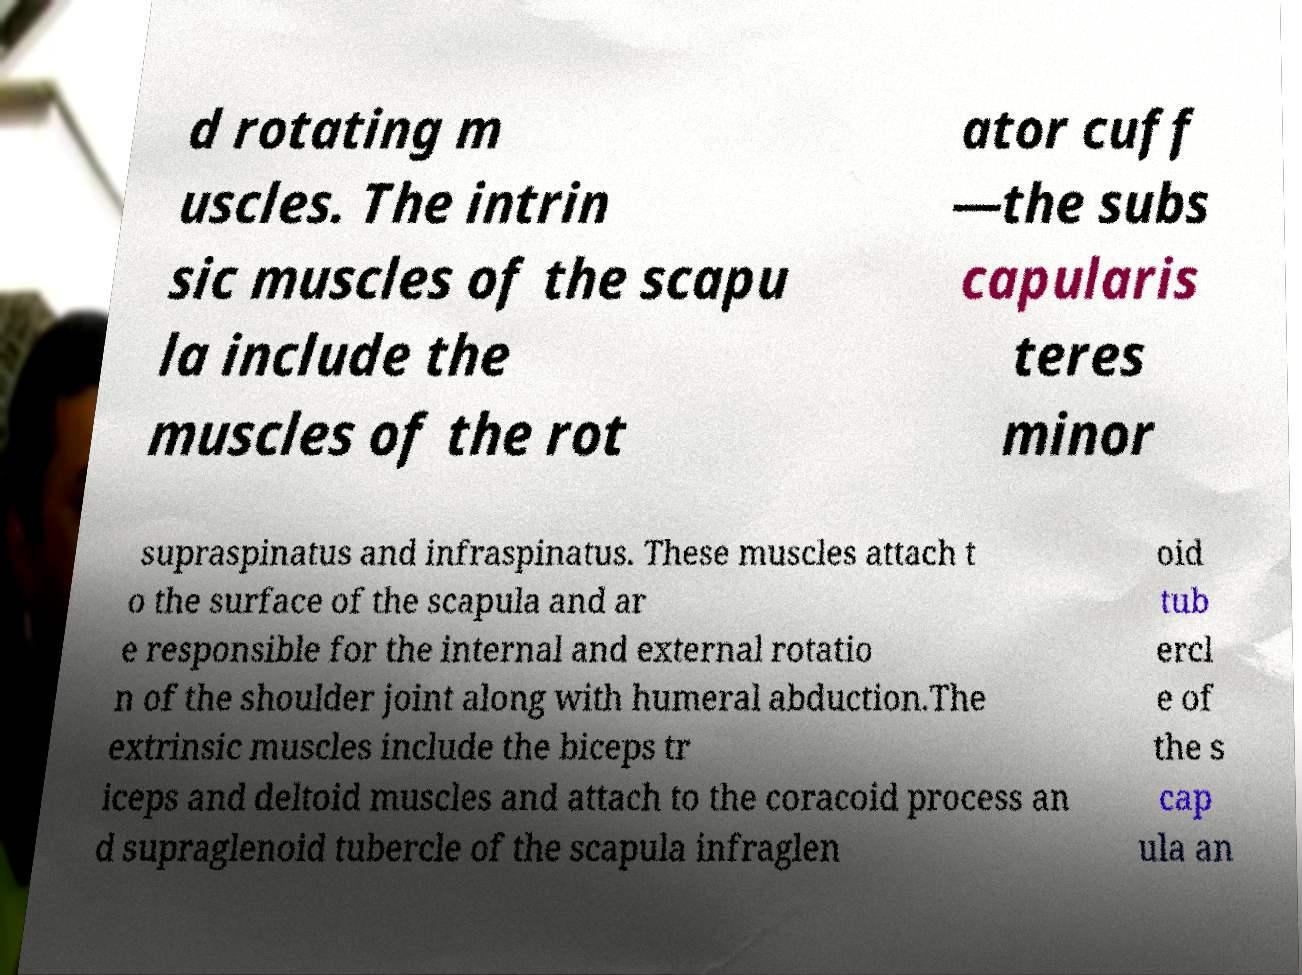Please identify and transcribe the text found in this image. d rotating m uscles. The intrin sic muscles of the scapu la include the muscles of the rot ator cuff —the subs capularis teres minor supraspinatus and infraspinatus. These muscles attach t o the surface of the scapula and ar e responsible for the internal and external rotatio n of the shoulder joint along with humeral abduction.The extrinsic muscles include the biceps tr iceps and deltoid muscles and attach to the coracoid process an d supraglenoid tubercle of the scapula infraglen oid tub ercl e of the s cap ula an 